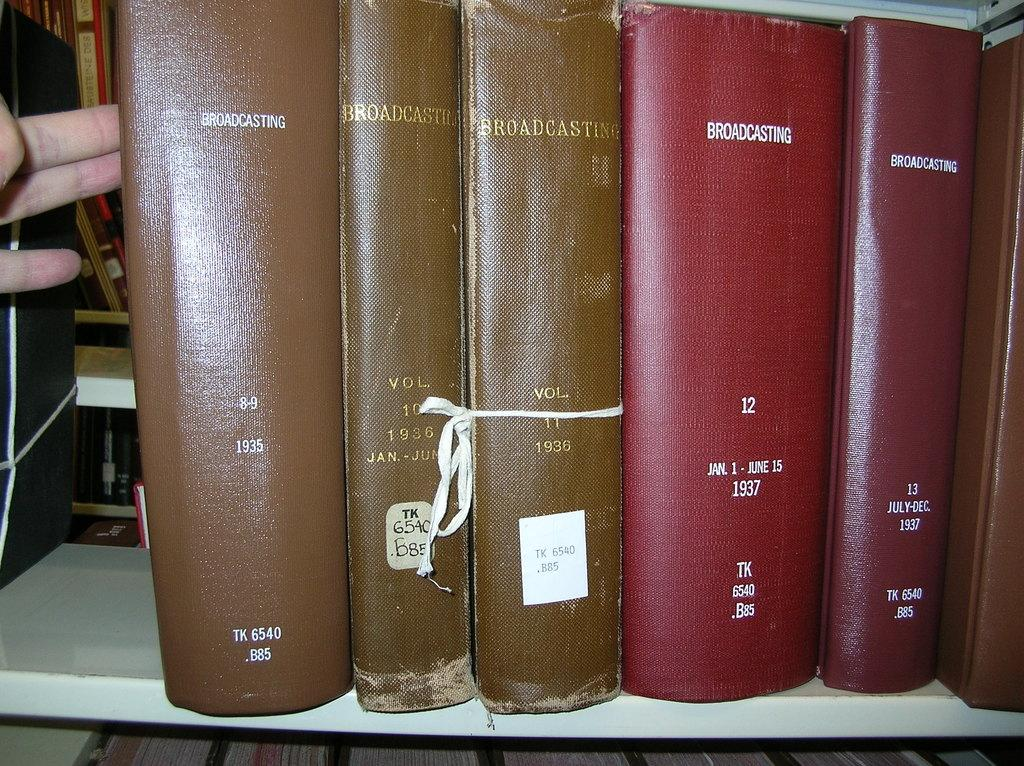<image>
Give a short and clear explanation of the subsequent image. A library shelf contains several different books on the subject of broadcasting. 